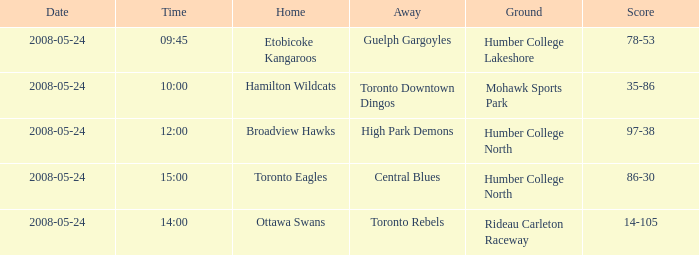On what day was the game that ended in a score of 97-38? 2008-05-24. 